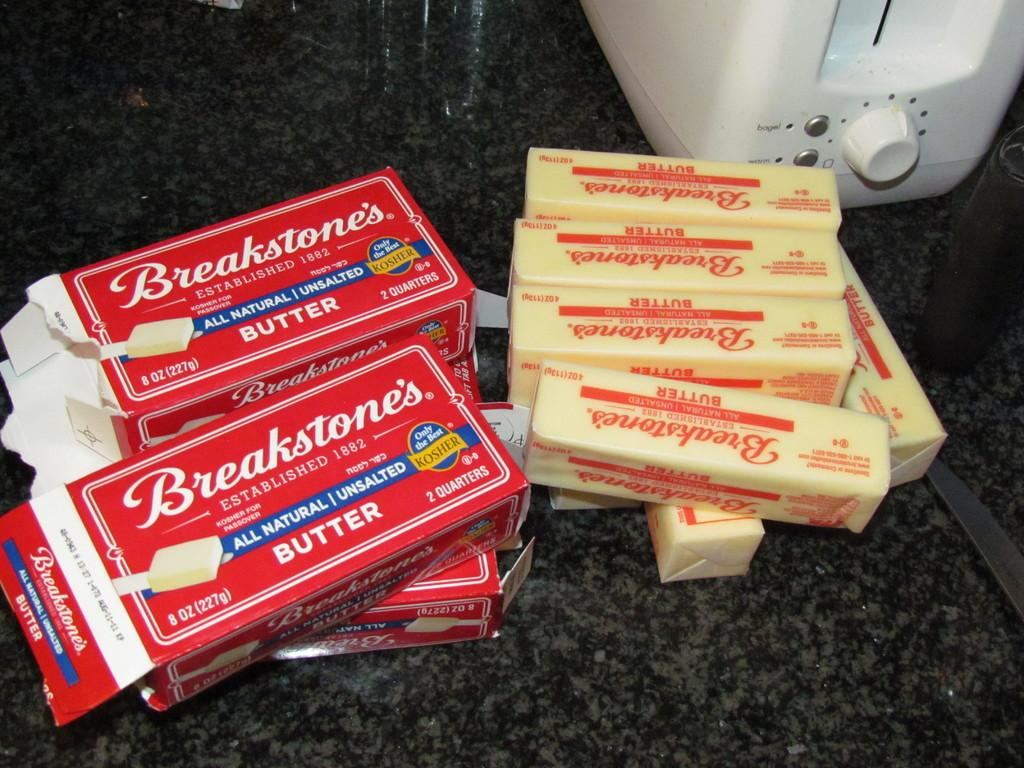<image>
Present a compact description of the photo's key features. brearkstones butter about 4 packs sit on the counter 